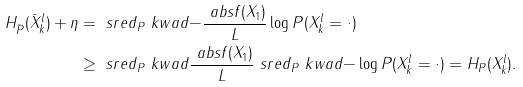Convert formula to latex. <formula><loc_0><loc_0><loc_500><loc_500>H _ { \bar { P } } ( \bar { X } _ { k } ^ { l } ) + \eta & = \ s r e d _ { P } \ k w a d { - \frac { \ a b s { f ( X _ { 1 } ) } } { L } \log P ( X _ { k } ^ { l } = \cdot ) } \\ & \geq \ s r e d _ { P } \ k w a d { \frac { \ a b s { f ( X _ { 1 } ) } } { L } } \ s r e d _ { P } \ k w a d { - \log P ( X _ { k } ^ { l } = \cdot ) } = H _ { P } ( X _ { k } ^ { l } ) .</formula> 